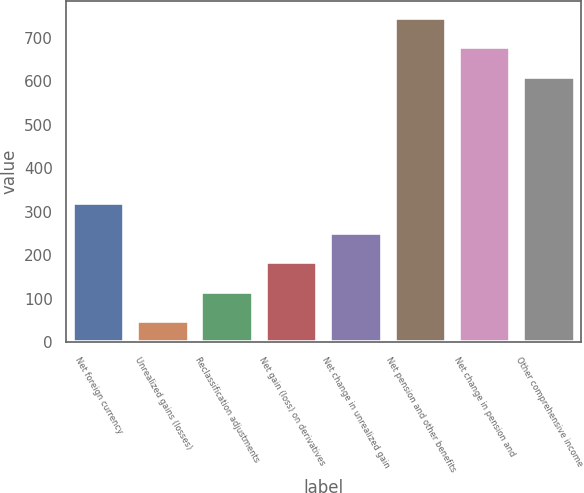Convert chart to OTSL. <chart><loc_0><loc_0><loc_500><loc_500><bar_chart><fcel>Net foreign currency<fcel>Unrealized gains (losses)<fcel>Reclassification adjustments<fcel>Net gain (loss) on derivatives<fcel>Net change in unrealized gain<fcel>Net pension and other benefits<fcel>Net change in pension and<fcel>Other comprehensive income<nl><fcel>319.6<fcel>48<fcel>115.9<fcel>183.8<fcel>251.7<fcel>746.8<fcel>678.9<fcel>611<nl></chart> 